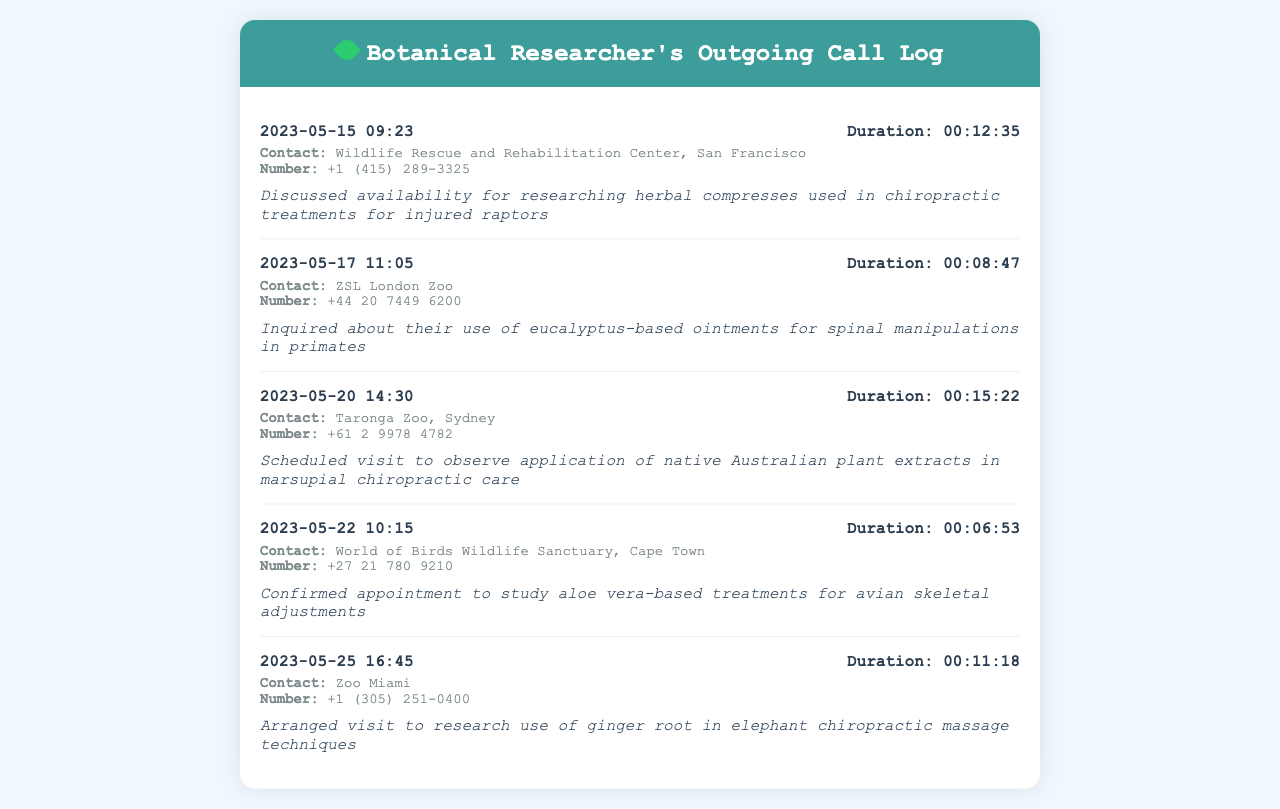what is the date of the first call? The first call occurred on May 15, 2023, as indicated by the call log's first entry.
Answer: May 15, 2023 which animal sanctuary was contacted on May 20, 2023? The call made on May 20, 2023, was to Taronga Zoo, as shown in the corresponding call entry.
Answer: Taronga Zoo how long was the call to Wildlife Rescue and Rehabilitation Center? The duration of the call to the Wildlife Rescue and Rehabilitation Center on May 15, 2023, is found next to the call header.
Answer: 00:12:35 which medicinal plant's treatment was discussed for avian skeletal adjustments? The document notes the study of aloe vera-based treatments for avian skeletal adjustments during the call on May 22, 2023.
Answer: aloe vera how many calls were made after May 22, 2023? By reviewing the dates of the calls, there are two entries after May 22, 2023, which require a clear count of calls.
Answer: 2 